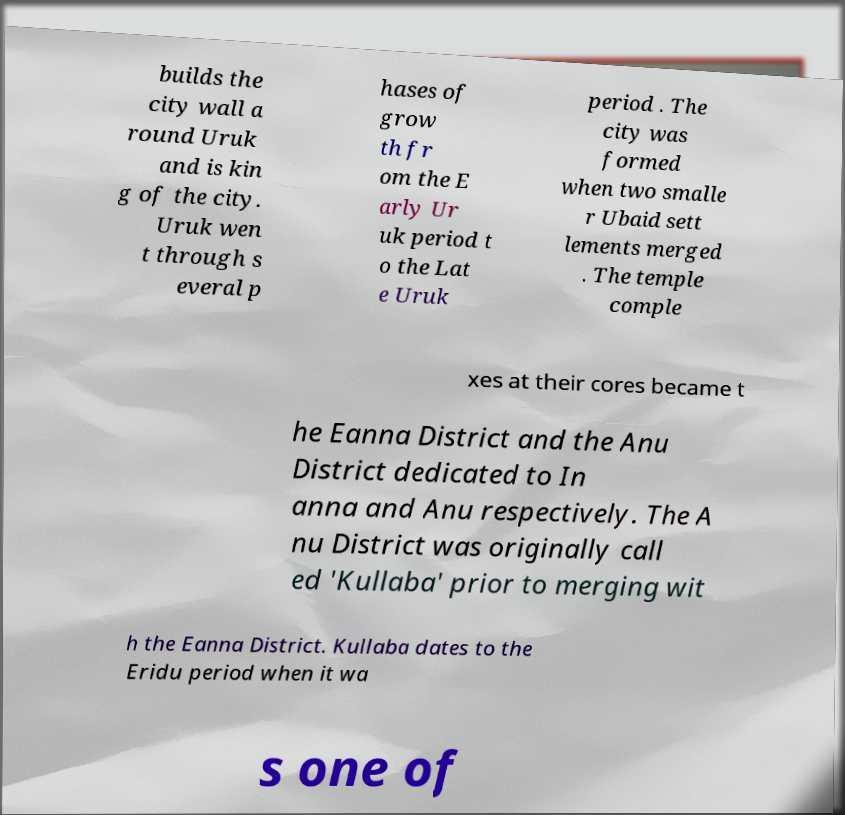Can you accurately transcribe the text from the provided image for me? builds the city wall a round Uruk and is kin g of the city. Uruk wen t through s everal p hases of grow th fr om the E arly Ur uk period t o the Lat e Uruk period . The city was formed when two smalle r Ubaid sett lements merged . The temple comple xes at their cores became t he Eanna District and the Anu District dedicated to In anna and Anu respectively. The A nu District was originally call ed 'Kullaba' prior to merging wit h the Eanna District. Kullaba dates to the Eridu period when it wa s one of 